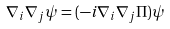Convert formula to latex. <formula><loc_0><loc_0><loc_500><loc_500>\nabla _ { i } \nabla _ { j } \psi = ( - i \nabla _ { i } \nabla _ { j } \Pi ) \psi</formula> 